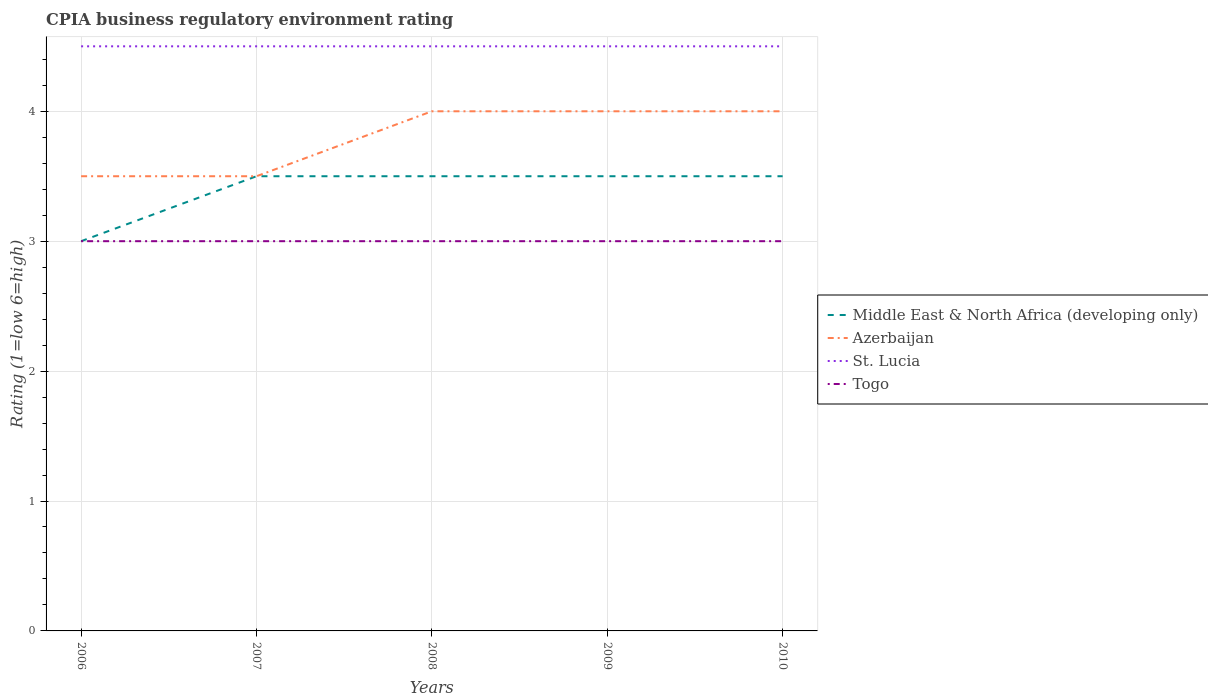Across all years, what is the maximum CPIA rating in Togo?
Provide a succinct answer. 3. In which year was the CPIA rating in Middle East & North Africa (developing only) maximum?
Ensure brevity in your answer.  2006. What is the total CPIA rating in Middle East & North Africa (developing only) in the graph?
Provide a short and direct response. 0. What is the difference between the highest and the second highest CPIA rating in St. Lucia?
Make the answer very short. 0. What is the difference between the highest and the lowest CPIA rating in Azerbaijan?
Offer a very short reply. 3. How many lines are there?
Your response must be concise. 4. What is the difference between two consecutive major ticks on the Y-axis?
Ensure brevity in your answer.  1. Are the values on the major ticks of Y-axis written in scientific E-notation?
Keep it short and to the point. No. Does the graph contain any zero values?
Provide a short and direct response. No. Does the graph contain grids?
Your answer should be very brief. Yes. Where does the legend appear in the graph?
Provide a succinct answer. Center right. How are the legend labels stacked?
Your response must be concise. Vertical. What is the title of the graph?
Keep it short and to the point. CPIA business regulatory environment rating. What is the label or title of the X-axis?
Your response must be concise. Years. What is the Rating (1=low 6=high) of Middle East & North Africa (developing only) in 2006?
Make the answer very short. 3. What is the Rating (1=low 6=high) of Azerbaijan in 2006?
Your response must be concise. 3.5. What is the Rating (1=low 6=high) of Togo in 2006?
Make the answer very short. 3. What is the Rating (1=low 6=high) in Togo in 2007?
Provide a succinct answer. 3. What is the Rating (1=low 6=high) in Azerbaijan in 2008?
Offer a terse response. 4. What is the Rating (1=low 6=high) of St. Lucia in 2008?
Give a very brief answer. 4.5. What is the Rating (1=low 6=high) in Togo in 2009?
Offer a terse response. 3. What is the Rating (1=low 6=high) in Middle East & North Africa (developing only) in 2010?
Give a very brief answer. 3.5. Across all years, what is the maximum Rating (1=low 6=high) of Middle East & North Africa (developing only)?
Offer a terse response. 3.5. Across all years, what is the maximum Rating (1=low 6=high) of St. Lucia?
Offer a terse response. 4.5. Across all years, what is the minimum Rating (1=low 6=high) in Middle East & North Africa (developing only)?
Your answer should be compact. 3. Across all years, what is the minimum Rating (1=low 6=high) in Azerbaijan?
Provide a short and direct response. 3.5. Across all years, what is the minimum Rating (1=low 6=high) of Togo?
Offer a terse response. 3. What is the total Rating (1=low 6=high) in Middle East & North Africa (developing only) in the graph?
Ensure brevity in your answer.  17. What is the total Rating (1=low 6=high) of Togo in the graph?
Make the answer very short. 15. What is the difference between the Rating (1=low 6=high) of Middle East & North Africa (developing only) in 2006 and that in 2007?
Offer a terse response. -0.5. What is the difference between the Rating (1=low 6=high) in Azerbaijan in 2006 and that in 2007?
Offer a terse response. 0. What is the difference between the Rating (1=low 6=high) of Azerbaijan in 2006 and that in 2008?
Give a very brief answer. -0.5. What is the difference between the Rating (1=low 6=high) in Togo in 2006 and that in 2008?
Offer a terse response. 0. What is the difference between the Rating (1=low 6=high) of Middle East & North Africa (developing only) in 2006 and that in 2009?
Make the answer very short. -0.5. What is the difference between the Rating (1=low 6=high) of Azerbaijan in 2006 and that in 2009?
Make the answer very short. -0.5. What is the difference between the Rating (1=low 6=high) in St. Lucia in 2006 and that in 2009?
Provide a succinct answer. 0. What is the difference between the Rating (1=low 6=high) in Middle East & North Africa (developing only) in 2006 and that in 2010?
Offer a very short reply. -0.5. What is the difference between the Rating (1=low 6=high) in Azerbaijan in 2007 and that in 2008?
Your answer should be very brief. -0.5. What is the difference between the Rating (1=low 6=high) of St. Lucia in 2007 and that in 2008?
Offer a terse response. 0. What is the difference between the Rating (1=low 6=high) of Togo in 2007 and that in 2008?
Provide a succinct answer. 0. What is the difference between the Rating (1=low 6=high) in Middle East & North Africa (developing only) in 2007 and that in 2009?
Your answer should be compact. 0. What is the difference between the Rating (1=low 6=high) of Azerbaijan in 2007 and that in 2009?
Provide a succinct answer. -0.5. What is the difference between the Rating (1=low 6=high) of Middle East & North Africa (developing only) in 2007 and that in 2010?
Provide a succinct answer. 0. What is the difference between the Rating (1=low 6=high) in Togo in 2007 and that in 2010?
Provide a succinct answer. 0. What is the difference between the Rating (1=low 6=high) in Togo in 2008 and that in 2009?
Offer a terse response. 0. What is the difference between the Rating (1=low 6=high) in Middle East & North Africa (developing only) in 2008 and that in 2010?
Make the answer very short. 0. What is the difference between the Rating (1=low 6=high) of Azerbaijan in 2008 and that in 2010?
Provide a succinct answer. 0. What is the difference between the Rating (1=low 6=high) of Togo in 2008 and that in 2010?
Offer a very short reply. 0. What is the difference between the Rating (1=low 6=high) of Azerbaijan in 2009 and that in 2010?
Your response must be concise. 0. What is the difference between the Rating (1=low 6=high) in Middle East & North Africa (developing only) in 2006 and the Rating (1=low 6=high) in Azerbaijan in 2007?
Your answer should be compact. -0.5. What is the difference between the Rating (1=low 6=high) in Middle East & North Africa (developing only) in 2006 and the Rating (1=low 6=high) in Togo in 2007?
Keep it short and to the point. 0. What is the difference between the Rating (1=low 6=high) of Azerbaijan in 2006 and the Rating (1=low 6=high) of Togo in 2007?
Offer a terse response. 0.5. What is the difference between the Rating (1=low 6=high) in St. Lucia in 2006 and the Rating (1=low 6=high) in Togo in 2007?
Offer a very short reply. 1.5. What is the difference between the Rating (1=low 6=high) in Middle East & North Africa (developing only) in 2006 and the Rating (1=low 6=high) in Togo in 2008?
Provide a succinct answer. 0. What is the difference between the Rating (1=low 6=high) of Azerbaijan in 2006 and the Rating (1=low 6=high) of Togo in 2008?
Provide a succinct answer. 0.5. What is the difference between the Rating (1=low 6=high) in St. Lucia in 2006 and the Rating (1=low 6=high) in Togo in 2008?
Ensure brevity in your answer.  1.5. What is the difference between the Rating (1=low 6=high) in Middle East & North Africa (developing only) in 2006 and the Rating (1=low 6=high) in Togo in 2009?
Offer a very short reply. 0. What is the difference between the Rating (1=low 6=high) of Azerbaijan in 2006 and the Rating (1=low 6=high) of Togo in 2009?
Ensure brevity in your answer.  0.5. What is the difference between the Rating (1=low 6=high) of St. Lucia in 2006 and the Rating (1=low 6=high) of Togo in 2009?
Your answer should be very brief. 1.5. What is the difference between the Rating (1=low 6=high) in Middle East & North Africa (developing only) in 2006 and the Rating (1=low 6=high) in Azerbaijan in 2010?
Offer a terse response. -1. What is the difference between the Rating (1=low 6=high) of Middle East & North Africa (developing only) in 2006 and the Rating (1=low 6=high) of St. Lucia in 2010?
Offer a terse response. -1.5. What is the difference between the Rating (1=low 6=high) in Middle East & North Africa (developing only) in 2006 and the Rating (1=low 6=high) in Togo in 2010?
Make the answer very short. 0. What is the difference between the Rating (1=low 6=high) of Azerbaijan in 2006 and the Rating (1=low 6=high) of St. Lucia in 2010?
Keep it short and to the point. -1. What is the difference between the Rating (1=low 6=high) of Azerbaijan in 2006 and the Rating (1=low 6=high) of Togo in 2010?
Keep it short and to the point. 0.5. What is the difference between the Rating (1=low 6=high) in St. Lucia in 2006 and the Rating (1=low 6=high) in Togo in 2010?
Give a very brief answer. 1.5. What is the difference between the Rating (1=low 6=high) in Middle East & North Africa (developing only) in 2007 and the Rating (1=low 6=high) in Togo in 2008?
Provide a short and direct response. 0.5. What is the difference between the Rating (1=low 6=high) of Azerbaijan in 2007 and the Rating (1=low 6=high) of Togo in 2008?
Your answer should be compact. 0.5. What is the difference between the Rating (1=low 6=high) of Middle East & North Africa (developing only) in 2007 and the Rating (1=low 6=high) of Togo in 2009?
Your answer should be compact. 0.5. What is the difference between the Rating (1=low 6=high) in Azerbaijan in 2007 and the Rating (1=low 6=high) in Togo in 2009?
Your answer should be compact. 0.5. What is the difference between the Rating (1=low 6=high) in Middle East & North Africa (developing only) in 2007 and the Rating (1=low 6=high) in St. Lucia in 2010?
Make the answer very short. -1. What is the difference between the Rating (1=low 6=high) of Azerbaijan in 2007 and the Rating (1=low 6=high) of St. Lucia in 2010?
Provide a short and direct response. -1. What is the difference between the Rating (1=low 6=high) in St. Lucia in 2007 and the Rating (1=low 6=high) in Togo in 2010?
Ensure brevity in your answer.  1.5. What is the difference between the Rating (1=low 6=high) in Middle East & North Africa (developing only) in 2008 and the Rating (1=low 6=high) in Azerbaijan in 2009?
Offer a terse response. -0.5. What is the difference between the Rating (1=low 6=high) of Azerbaijan in 2008 and the Rating (1=low 6=high) of Togo in 2009?
Ensure brevity in your answer.  1. What is the difference between the Rating (1=low 6=high) of St. Lucia in 2008 and the Rating (1=low 6=high) of Togo in 2009?
Make the answer very short. 1.5. What is the difference between the Rating (1=low 6=high) of Middle East & North Africa (developing only) in 2008 and the Rating (1=low 6=high) of St. Lucia in 2010?
Your answer should be very brief. -1. What is the difference between the Rating (1=low 6=high) in Middle East & North Africa (developing only) in 2008 and the Rating (1=low 6=high) in Togo in 2010?
Offer a terse response. 0.5. What is the difference between the Rating (1=low 6=high) in St. Lucia in 2008 and the Rating (1=low 6=high) in Togo in 2010?
Offer a very short reply. 1.5. What is the difference between the Rating (1=low 6=high) in Middle East & North Africa (developing only) in 2009 and the Rating (1=low 6=high) in Azerbaijan in 2010?
Your answer should be very brief. -0.5. What is the difference between the Rating (1=low 6=high) in Middle East & North Africa (developing only) in 2009 and the Rating (1=low 6=high) in St. Lucia in 2010?
Provide a succinct answer. -1. What is the difference between the Rating (1=low 6=high) of Middle East & North Africa (developing only) in 2009 and the Rating (1=low 6=high) of Togo in 2010?
Your answer should be compact. 0.5. What is the difference between the Rating (1=low 6=high) of St. Lucia in 2009 and the Rating (1=low 6=high) of Togo in 2010?
Provide a short and direct response. 1.5. What is the average Rating (1=low 6=high) in Togo per year?
Ensure brevity in your answer.  3. In the year 2006, what is the difference between the Rating (1=low 6=high) of Middle East & North Africa (developing only) and Rating (1=low 6=high) of Azerbaijan?
Provide a short and direct response. -0.5. In the year 2006, what is the difference between the Rating (1=low 6=high) in Middle East & North Africa (developing only) and Rating (1=low 6=high) in Togo?
Your response must be concise. 0. In the year 2006, what is the difference between the Rating (1=low 6=high) in Azerbaijan and Rating (1=low 6=high) in St. Lucia?
Provide a succinct answer. -1. In the year 2006, what is the difference between the Rating (1=low 6=high) in St. Lucia and Rating (1=low 6=high) in Togo?
Your response must be concise. 1.5. In the year 2007, what is the difference between the Rating (1=low 6=high) of Middle East & North Africa (developing only) and Rating (1=low 6=high) of Azerbaijan?
Offer a terse response. 0. In the year 2007, what is the difference between the Rating (1=low 6=high) of Azerbaijan and Rating (1=low 6=high) of St. Lucia?
Provide a short and direct response. -1. In the year 2007, what is the difference between the Rating (1=low 6=high) of Azerbaijan and Rating (1=low 6=high) of Togo?
Provide a succinct answer. 0.5. In the year 2008, what is the difference between the Rating (1=low 6=high) of Azerbaijan and Rating (1=low 6=high) of St. Lucia?
Ensure brevity in your answer.  -0.5. In the year 2008, what is the difference between the Rating (1=low 6=high) of St. Lucia and Rating (1=low 6=high) of Togo?
Offer a very short reply. 1.5. In the year 2009, what is the difference between the Rating (1=low 6=high) in Azerbaijan and Rating (1=low 6=high) in St. Lucia?
Your response must be concise. -0.5. In the year 2009, what is the difference between the Rating (1=low 6=high) in St. Lucia and Rating (1=low 6=high) in Togo?
Make the answer very short. 1.5. In the year 2010, what is the difference between the Rating (1=low 6=high) of Middle East & North Africa (developing only) and Rating (1=low 6=high) of Azerbaijan?
Make the answer very short. -0.5. In the year 2010, what is the difference between the Rating (1=low 6=high) of Middle East & North Africa (developing only) and Rating (1=low 6=high) of St. Lucia?
Give a very brief answer. -1. In the year 2010, what is the difference between the Rating (1=low 6=high) in Middle East & North Africa (developing only) and Rating (1=low 6=high) in Togo?
Offer a very short reply. 0.5. What is the ratio of the Rating (1=low 6=high) in Azerbaijan in 2006 to that in 2007?
Offer a very short reply. 1. What is the ratio of the Rating (1=low 6=high) of Togo in 2006 to that in 2008?
Provide a succinct answer. 1. What is the ratio of the Rating (1=low 6=high) in Middle East & North Africa (developing only) in 2006 to that in 2009?
Offer a terse response. 0.86. What is the ratio of the Rating (1=low 6=high) of St. Lucia in 2006 to that in 2009?
Your response must be concise. 1. What is the ratio of the Rating (1=low 6=high) of Middle East & North Africa (developing only) in 2007 to that in 2008?
Your answer should be compact. 1. What is the ratio of the Rating (1=low 6=high) in St. Lucia in 2007 to that in 2008?
Keep it short and to the point. 1. What is the ratio of the Rating (1=low 6=high) in Middle East & North Africa (developing only) in 2007 to that in 2009?
Offer a very short reply. 1. What is the ratio of the Rating (1=low 6=high) in Middle East & North Africa (developing only) in 2007 to that in 2010?
Provide a succinct answer. 1. What is the ratio of the Rating (1=low 6=high) of Azerbaijan in 2007 to that in 2010?
Offer a terse response. 0.88. What is the ratio of the Rating (1=low 6=high) of St. Lucia in 2007 to that in 2010?
Give a very brief answer. 1. What is the ratio of the Rating (1=low 6=high) of Togo in 2007 to that in 2010?
Offer a very short reply. 1. What is the ratio of the Rating (1=low 6=high) in Azerbaijan in 2008 to that in 2009?
Give a very brief answer. 1. What is the ratio of the Rating (1=low 6=high) of St. Lucia in 2008 to that in 2009?
Offer a terse response. 1. What is the ratio of the Rating (1=low 6=high) of Middle East & North Africa (developing only) in 2008 to that in 2010?
Offer a very short reply. 1. What is the ratio of the Rating (1=low 6=high) of St. Lucia in 2008 to that in 2010?
Provide a succinct answer. 1. What is the ratio of the Rating (1=low 6=high) of Togo in 2008 to that in 2010?
Provide a short and direct response. 1. What is the ratio of the Rating (1=low 6=high) of Middle East & North Africa (developing only) in 2009 to that in 2010?
Your answer should be very brief. 1. What is the difference between the highest and the second highest Rating (1=low 6=high) of Azerbaijan?
Offer a terse response. 0. What is the difference between the highest and the second highest Rating (1=low 6=high) in Togo?
Offer a very short reply. 0. 